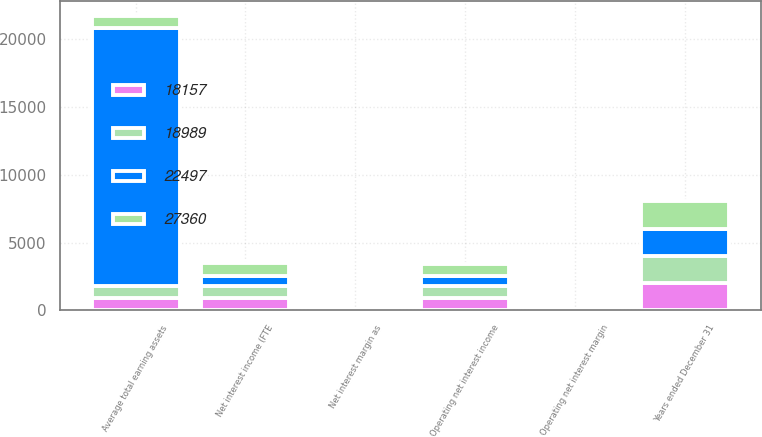Convert chart to OTSL. <chart><loc_0><loc_0><loc_500><loc_500><stacked_bar_chart><ecel><fcel>Years ended December 31<fcel>Net interest income (FTE<fcel>Operating net interest income<fcel>Net interest margin as<fcel>Operating net interest margin<fcel>Average total earning assets<nl><fcel>18157<fcel>2013<fcel>905.8<fcel>905.8<fcel>3.31<fcel>3.31<fcel>905<nl><fcel>27360<fcel>2012<fcel>940.4<fcel>931.6<fcel>3.86<fcel>3.82<fcel>905<nl><fcel>18989<fcel>2011<fcel>921.2<fcel>905<fcel>4.1<fcel>4.03<fcel>905<nl><fcel>22497<fcel>2010<fcel>697.3<fcel>697.3<fcel>3.67<fcel>3.67<fcel>18989<nl></chart> 